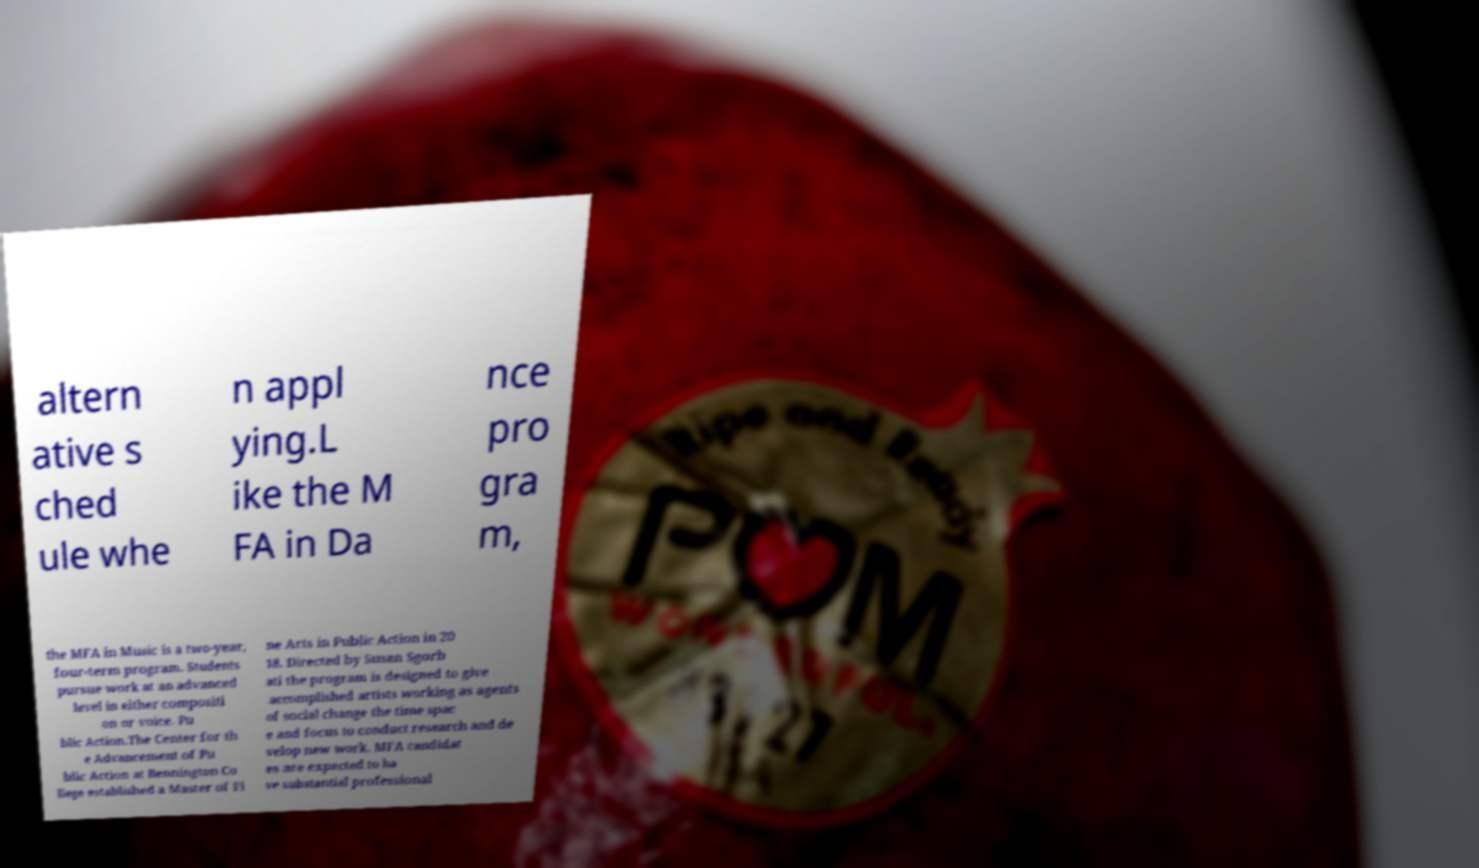What messages or text are displayed in this image? I need them in a readable, typed format. altern ative s ched ule whe n appl ying.L ike the M FA in Da nce pro gra m, the MFA in Music is a two-year, four-term program. Students pursue work at an advanced level in either compositi on or voice. Pu blic Action.The Center for th e Advancement of Pu blic Action at Bennington Co llege established a Master of Fi ne Arts in Public Action in 20 18. Directed by Susan Sgorb ati the program is designed to give accomplished artists working as agents of social change the time spac e and focus to conduct research and de velop new work. MFA candidat es are expected to ha ve substantial professional 